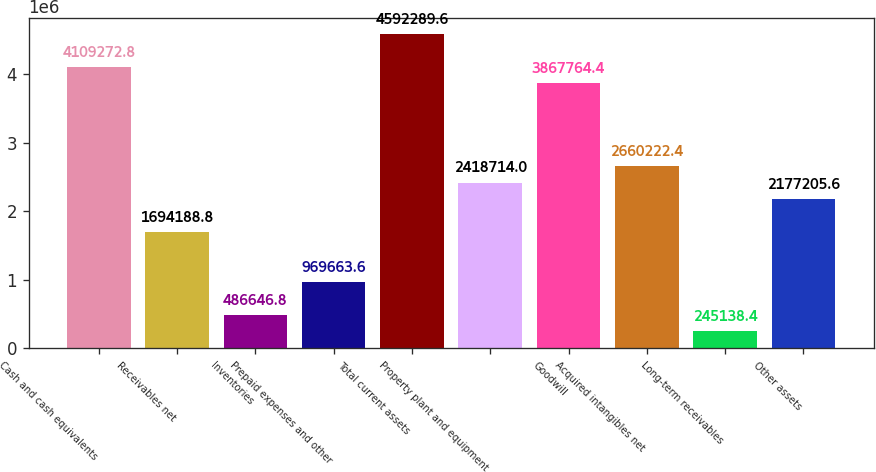Convert chart to OTSL. <chart><loc_0><loc_0><loc_500><loc_500><bar_chart><fcel>Cash and cash equivalents<fcel>Receivables net<fcel>Inventories<fcel>Prepaid expenses and other<fcel>Total current assets<fcel>Property plant and equipment<fcel>Goodwill<fcel>Acquired intangibles net<fcel>Long-term receivables<fcel>Other assets<nl><fcel>4.10927e+06<fcel>1.69419e+06<fcel>486647<fcel>969664<fcel>4.59229e+06<fcel>2.41871e+06<fcel>3.86776e+06<fcel>2.66022e+06<fcel>245138<fcel>2.17721e+06<nl></chart> 